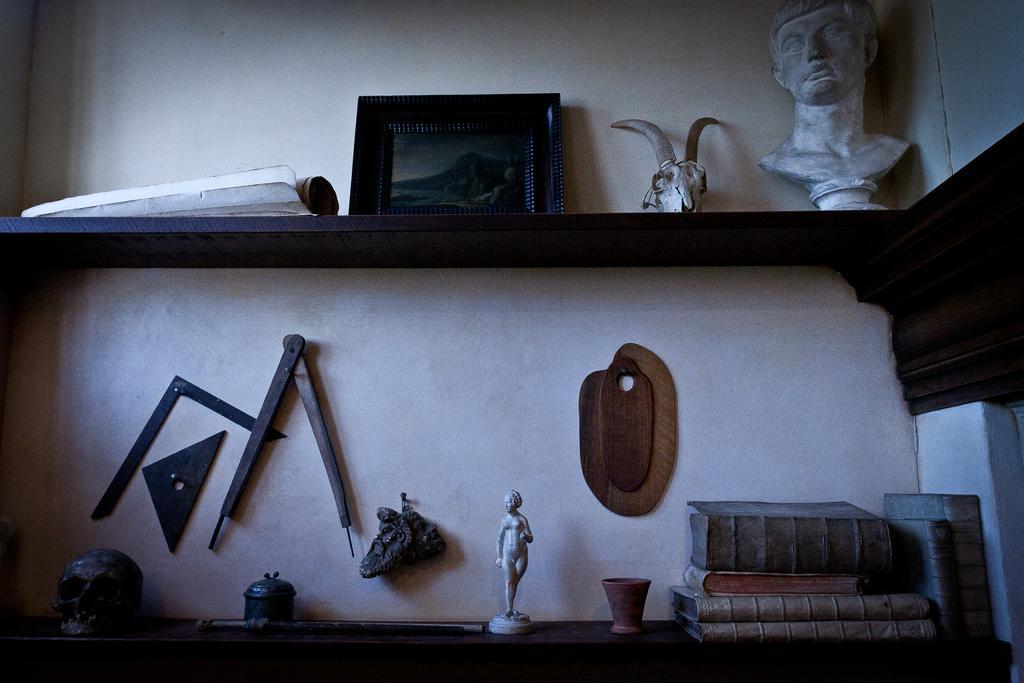Could you give a brief overview of what you see in this image? In this image, I can see a photo frame, sculptures, books, skull and few other objects placed in the racks. There are few objects attached to the wall. 